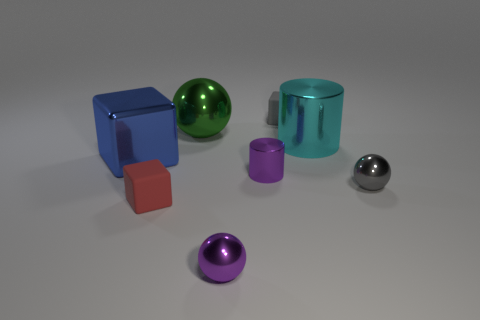There is a small purple metallic thing that is behind the gray shiny thing; what number of green balls are right of it?
Provide a succinct answer. 0. Does the small thing that is right of the gray rubber thing have the same material as the large green ball that is behind the small purple ball?
Ensure brevity in your answer.  Yes. There is a object that is the same color as the tiny cylinder; what is it made of?
Keep it short and to the point. Metal. How many other large blue metal things are the same shape as the blue shiny thing?
Your response must be concise. 0. Is the material of the tiny gray ball the same as the cylinder on the right side of the tiny gray matte thing?
Keep it short and to the point. Yes. What is the material of the green ball that is the same size as the metal block?
Offer a very short reply. Metal. Are there any green balls that have the same size as the green thing?
Keep it short and to the point. No. The red thing that is the same size as the purple cylinder is what shape?
Your answer should be very brief. Cube. What number of other things are there of the same color as the big sphere?
Keep it short and to the point. 0. The metallic object that is both behind the purple metallic cylinder and in front of the big cyan shiny thing has what shape?
Offer a very short reply. Cube. 